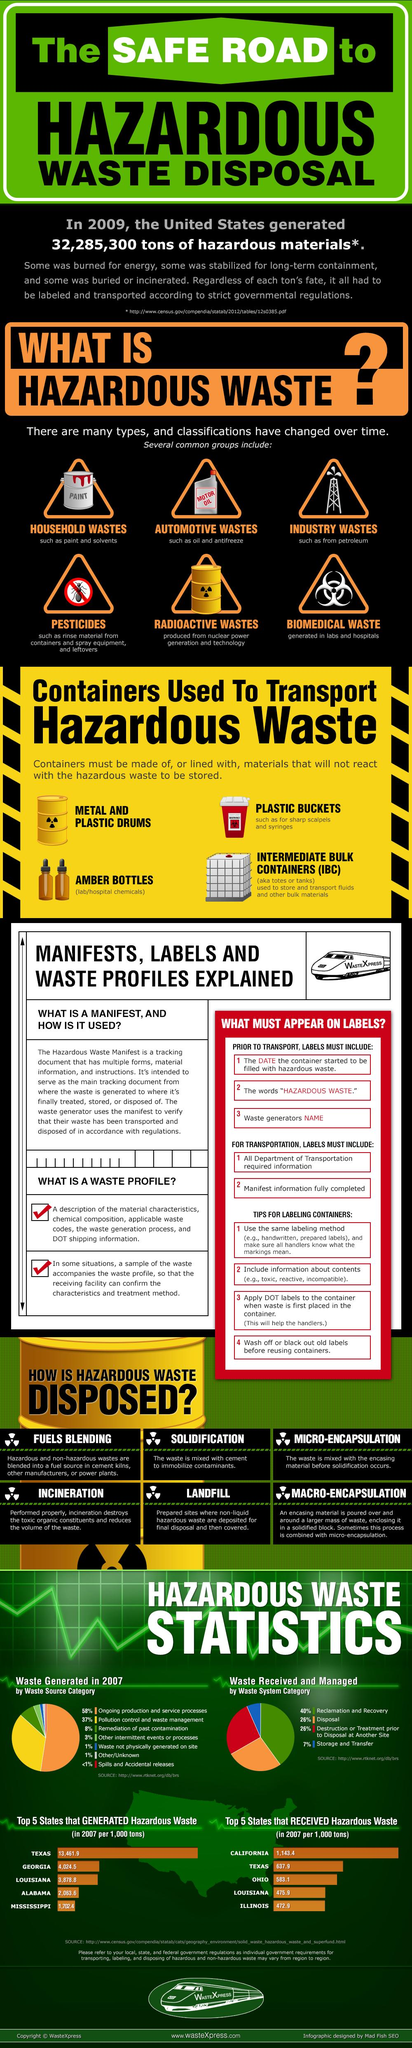Identify some key points in this picture. The image lists four types of containers that are used to transport hazardous waste. Six common groups of hazardous waste are listed in the image. Biomedical waste is generated from laboratories, as well as industries and radioactive sources. 